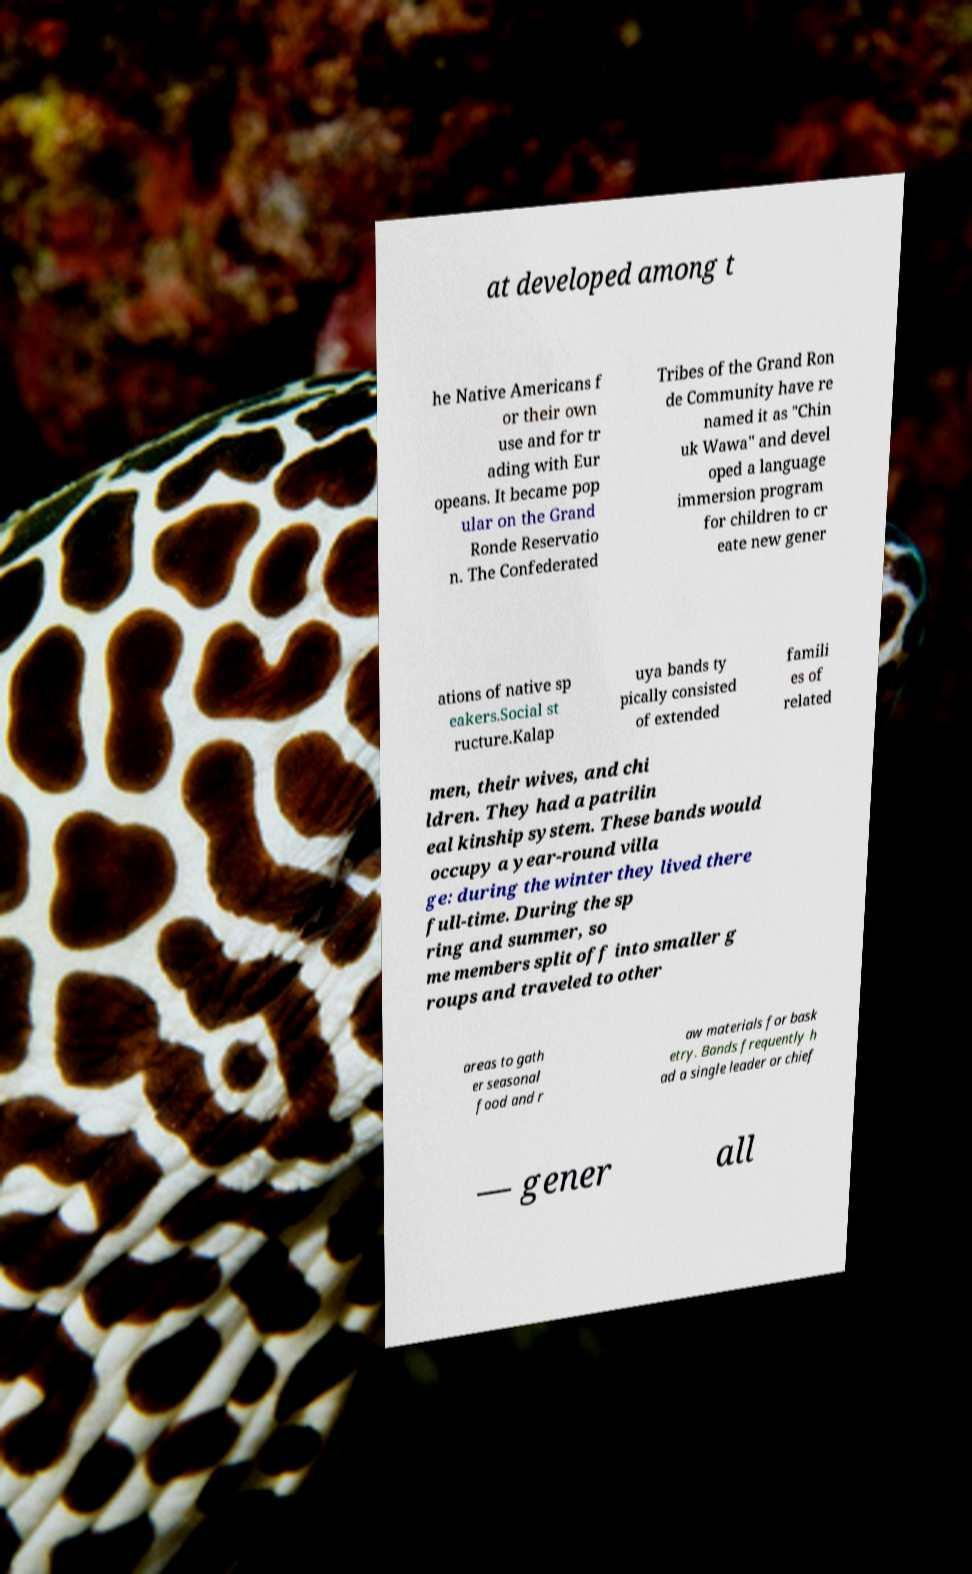Please identify and transcribe the text found in this image. at developed among t he Native Americans f or their own use and for tr ading with Eur opeans. It became pop ular on the Grand Ronde Reservatio n. The Confederated Tribes of the Grand Ron de Community have re named it as "Chin uk Wawa" and devel oped a language immersion program for children to cr eate new gener ations of native sp eakers.Social st ructure.Kalap uya bands ty pically consisted of extended famili es of related men, their wives, and chi ldren. They had a patrilin eal kinship system. These bands would occupy a year-round villa ge: during the winter they lived there full-time. During the sp ring and summer, so me members split off into smaller g roups and traveled to other areas to gath er seasonal food and r aw materials for bask etry. Bands frequently h ad a single leader or chief — gener all 